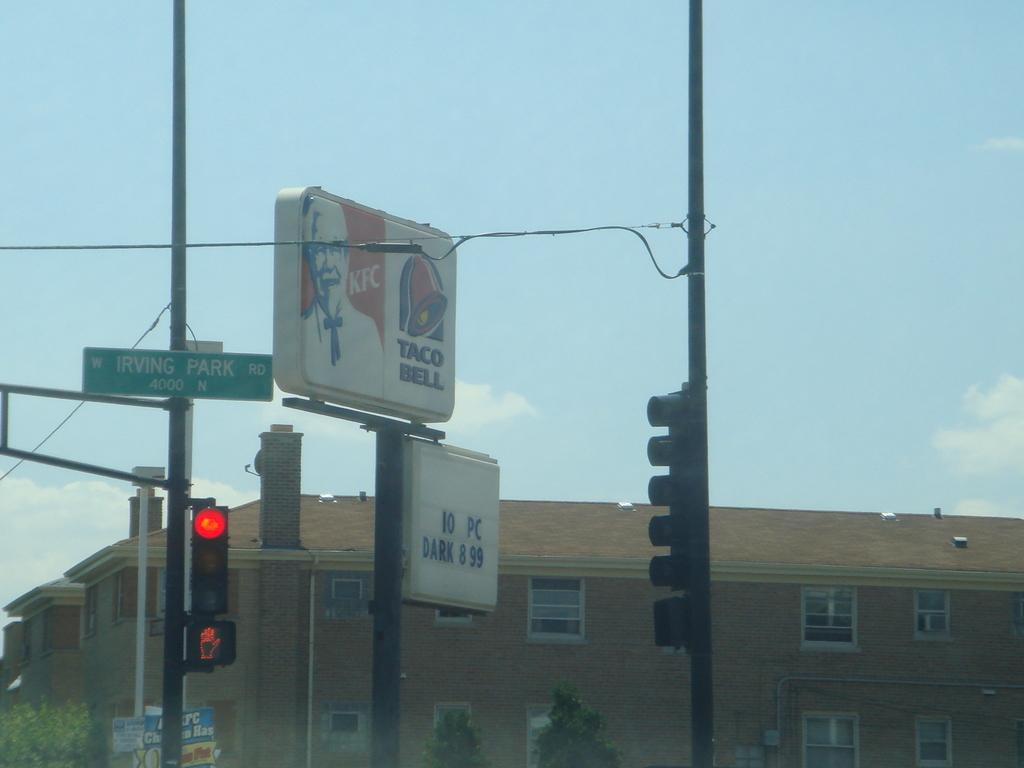<image>
Relay a brief, clear account of the picture shown. A splitsign that has Kentucky Friend Chicken and Taco Bell advertised. 